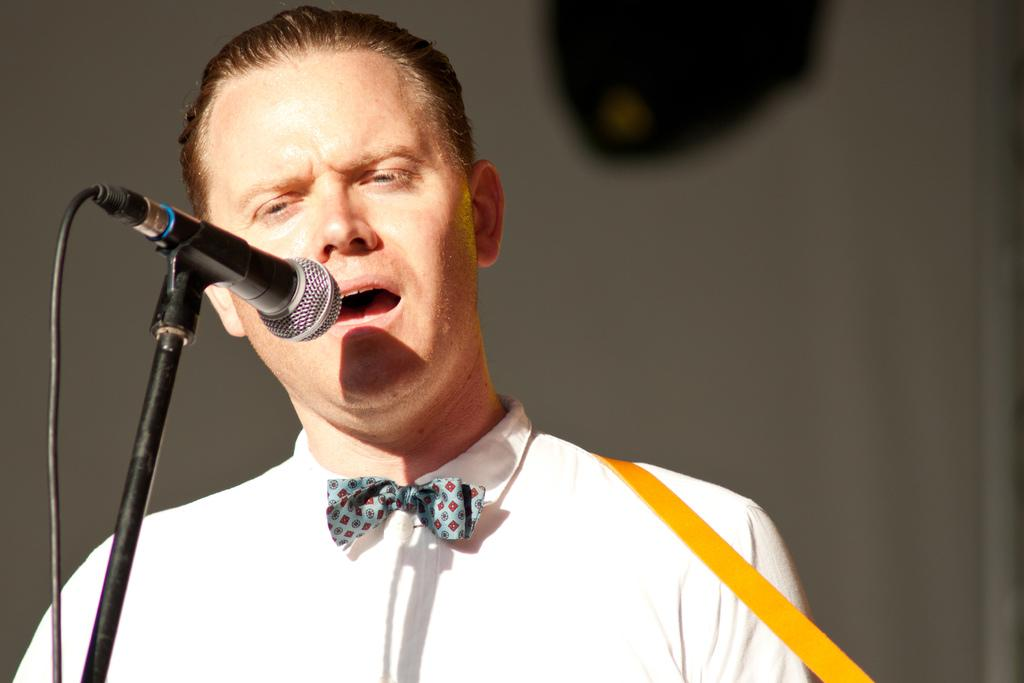Who is present in the image? There is a man in the image. What is the man doing in the image? The man is smiling in the image. What is the man wearing in the image? The man is wearing a white shirt and a bow tie in the image. What object can be seen on the left side of the image? There is a microphone on the left side of the image. How would you describe the background of the image? The background of the image is blurry. How many rings can be seen on the man's fingers in the image? There are no rings visible on the man's fingers in the image. Is there a sink present in the image? There is no sink present in the image. 